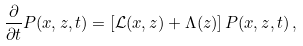Convert formula to latex. <formula><loc_0><loc_0><loc_500><loc_500>\frac { \partial } { \partial t } P ( x , z , t ) = \left [ { \mathcal { L } } ( x , z ) + \Lambda ( z ) \right ] P ( x , z , t ) \, ,</formula> 